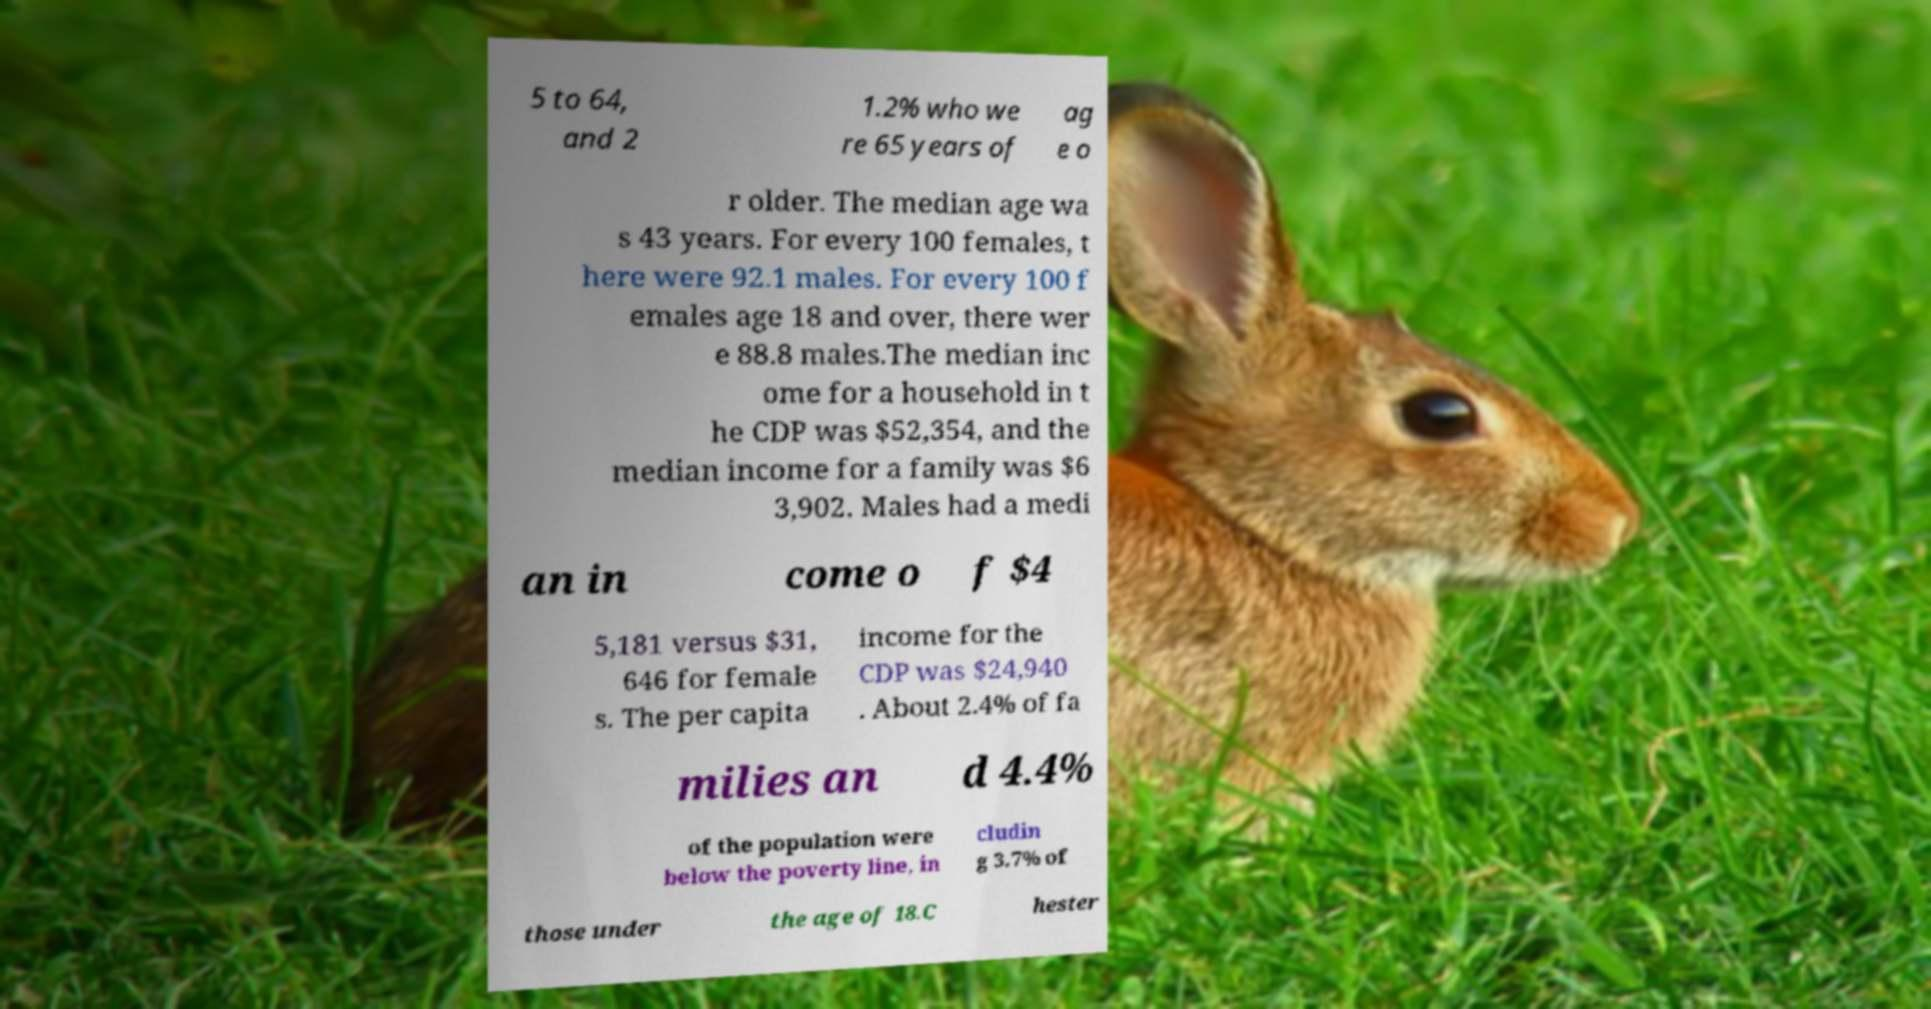I need the written content from this picture converted into text. Can you do that? 5 to 64, and 2 1.2% who we re 65 years of ag e o r older. The median age wa s 43 years. For every 100 females, t here were 92.1 males. For every 100 f emales age 18 and over, there wer e 88.8 males.The median inc ome for a household in t he CDP was $52,354, and the median income for a family was $6 3,902. Males had a medi an in come o f $4 5,181 versus $31, 646 for female s. The per capita income for the CDP was $24,940 . About 2.4% of fa milies an d 4.4% of the population were below the poverty line, in cludin g 3.7% of those under the age of 18.C hester 